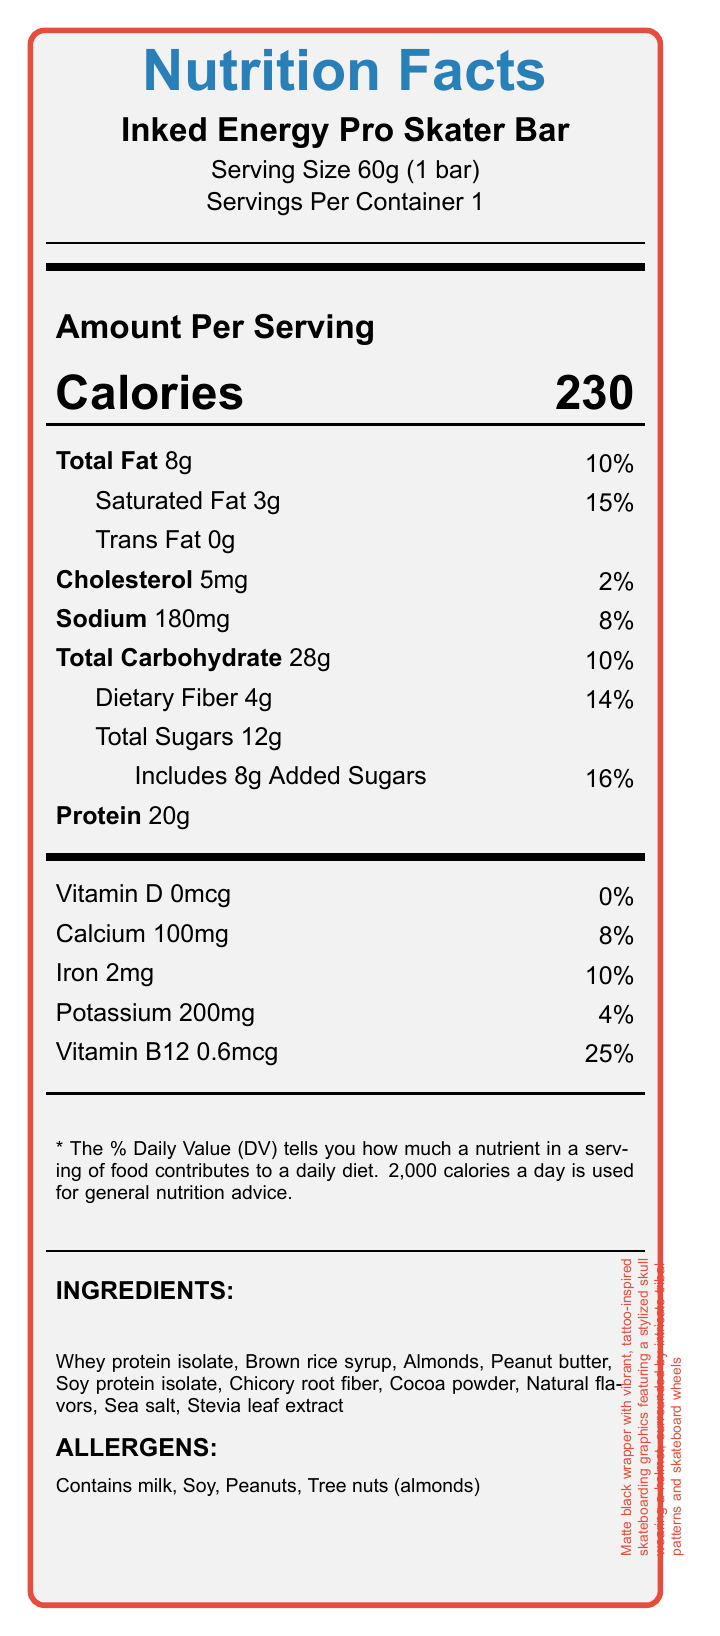what is the serving size of the Inked Energy Pro Skater Bar? The serving size is stated as "Serving Size 60g (1 bar)" in the document.
Answer: 60g (1 bar) how many grams of total fat are in one serving? The document states "Total Fat 8g".
Answer: 8g what percentage of the Daily Value for saturated fat does one bar provide? The percentage of the Daily Value for saturated fat is listed as "15%" in the document.
Answer: 15% how much protein does the Inked Energy Pro Skater Bar contain? The document mentions "Protein 20g".
Answer: 20g what's the amount of cholesterol in the bar? The document lists "Cholesterol 5mg".
Answer: 5mg what is the calorie content of one Inked Energy Pro Skater Bar? The document states "Calories 230".
Answer: 230 calories does the bar contain any trans fat? The document clearly states "Trans Fat 0g".
Answer: No which ingredient comes first in the list of ingredients? A. Peanut butter B. Soy protein isolate C. Whey protein isolate D. Stevia leaf extract The first ingredient listed is "Whey protein isolate".
Answer: C how many allergen warnings are there on the label? A. Two B. Three C. Four D. Five The allergen warnings listed are "Contains milk, Soy, Peanuts, Tree nuts (almonds)", which makes a total of four.
Answer: C is the bar suitable for someone with a peanut allergy? The document states that the bar contains peanuts, which makes it unsuitable for someone with a peanut allergy.
Answer: No what are the tattoos on the packaging inspired by? The packaging description mentions "tattoo-inspired skateboarding graphics featuring a stylized skull wearing a helmet, surrounded by intricate tribal patterns and skateboard wheels".
Answer: Skateboarding summarize the main idea of the document. The document aggregates nutritional data and design details for the product, helping consumers understand what they are consuming and the artistic inspiration behind its packaging.
Answer: The document provides the nutritional information and packaging description for the "Inked Energy Pro Skater Bar". It includes detailed information on serving size, calorie content, fat, cholesterol, sodium, carbohydrate, dietary fiber, sugars, proteins, vitamins, and minerals. The packaging features a matte black wrapper with vibrant tattoo-inspired skateboarding graphics. how does the dietary fiber content compare to its Daily Value? According to the document, dietary fiber content is listed as "Dietary Fiber 4g" and its Daily Value percentage is "14%".
Answer: 4g which is 14% of Daily Value what is the main source of protein in the bar? Based on the list of ingredients, the primary source of protein appears to be "Whey protein isolate".
Answer: Whey protein isolate does the bar include any added sugars? The label specifies that the bar includes "8g Added Sugars".
Answer: Yes how much calcium does one bar provide as a percentage of the Daily Value? The document lists "Calcium 100mg" with a Daily Value percentage of "8%".
Answer: 8% what type of sweetener is used in the bar? The ingredients list mentions "Stevia leaf extract" as the sweetener used.
Answer: Stevia leaf extract which component has a notably high Daily Value percentage? The document mentions "Vitamin B12 0.6mcg" contributing to "25%" of the Daily Value, which is notably high compared to other components.
Answer: Vitamin B12 with 25% what is the sodium content per serving? The document lists "Sodium 180mg".
Answer: 180mg can we determine the manufacturing location of the bar from the document? The document does not provide any information regarding the manufacturing location of the bar.
Answer: Cannot be determined what description is given for the wrapper design? The packaging description provides a detailed visual portrayal of the wrapper design.
Answer: Matte black wrapper with vibrant, tattoo-inspired skateboarding graphics featuring a stylized skull wearing a helmet, surrounded by intricate tribal patterns and skateboard wheels 